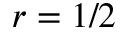<formula> <loc_0><loc_0><loc_500><loc_500>r = 1 / 2</formula> 